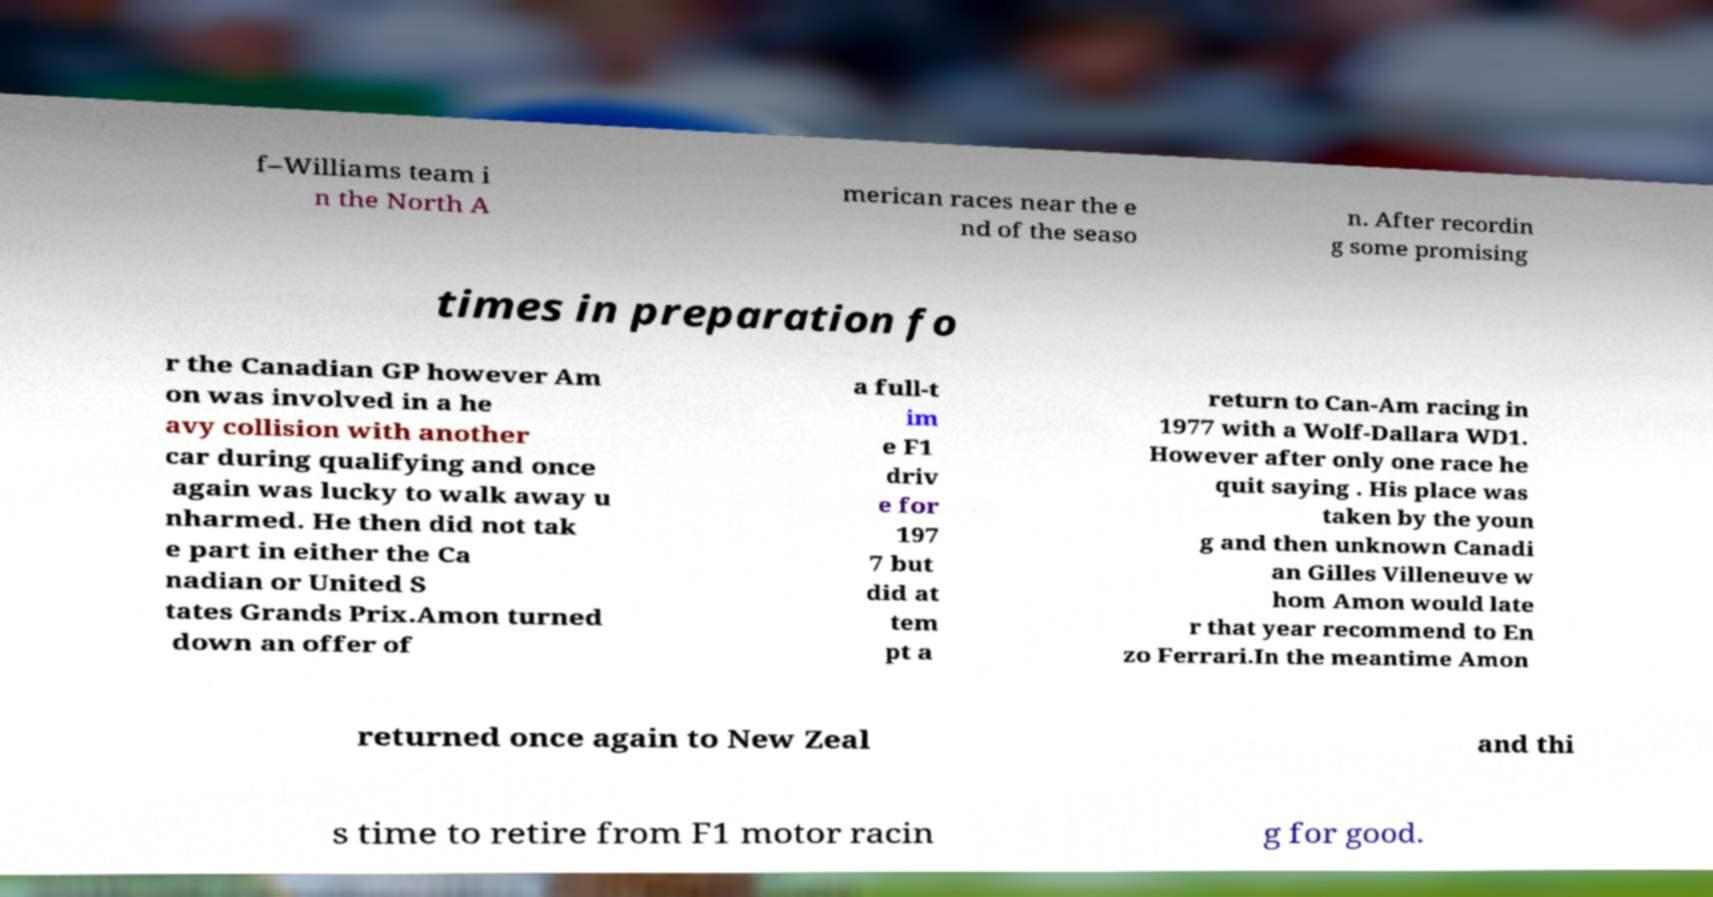Could you assist in decoding the text presented in this image and type it out clearly? f–Williams team i n the North A merican races near the e nd of the seaso n. After recordin g some promising times in preparation fo r the Canadian GP however Am on was involved in a he avy collision with another car during qualifying and once again was lucky to walk away u nharmed. He then did not tak e part in either the Ca nadian or United S tates Grands Prix.Amon turned down an offer of a full-t im e F1 driv e for 197 7 but did at tem pt a return to Can-Am racing in 1977 with a Wolf-Dallara WD1. However after only one race he quit saying . His place was taken by the youn g and then unknown Canadi an Gilles Villeneuve w hom Amon would late r that year recommend to En zo Ferrari.In the meantime Amon returned once again to New Zeal and thi s time to retire from F1 motor racin g for good. 